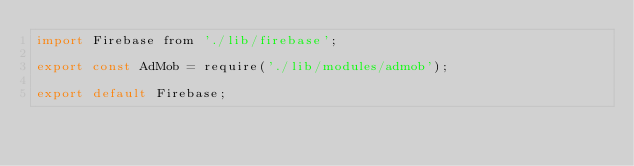Convert code to text. <code><loc_0><loc_0><loc_500><loc_500><_JavaScript_>import Firebase from './lib/firebase';

export const AdMob = require('./lib/modules/admob');

export default Firebase;
</code> 